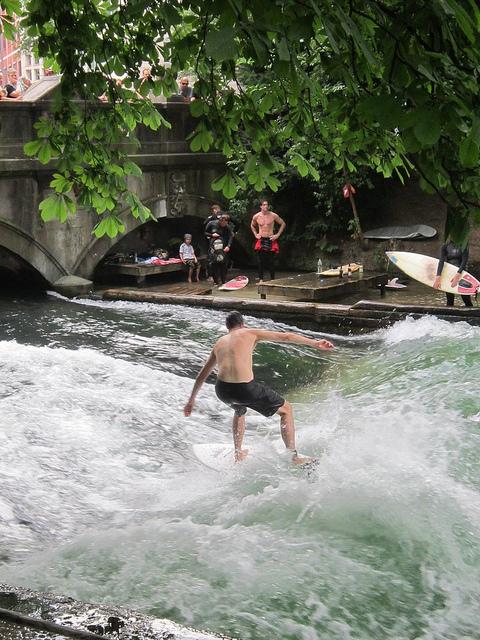Is he surfing on the ocean?
Concise answer only. No. What is the man standing on?
Write a very short answer. Surfboard. What are these people doing?
Be succinct. Surfing. 